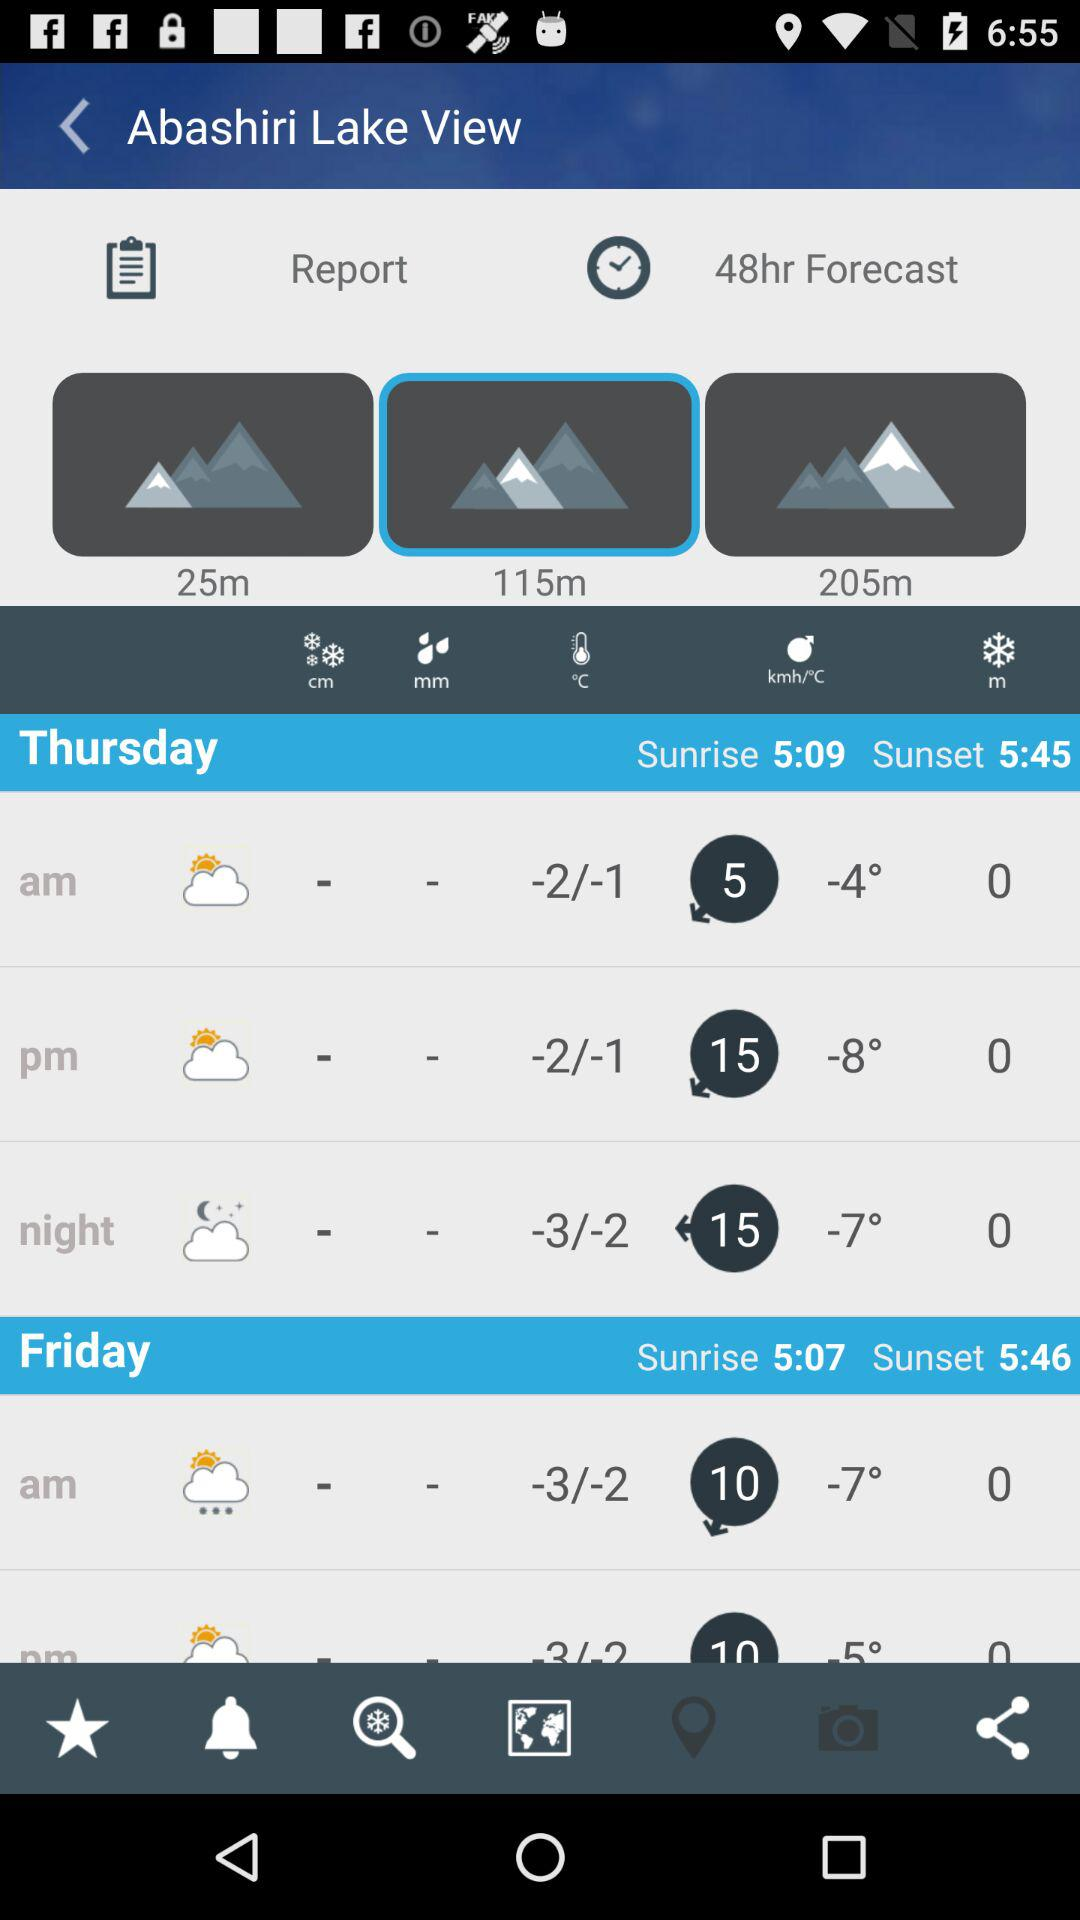What is the forecast time period? The forecast time period is 48 hours. 